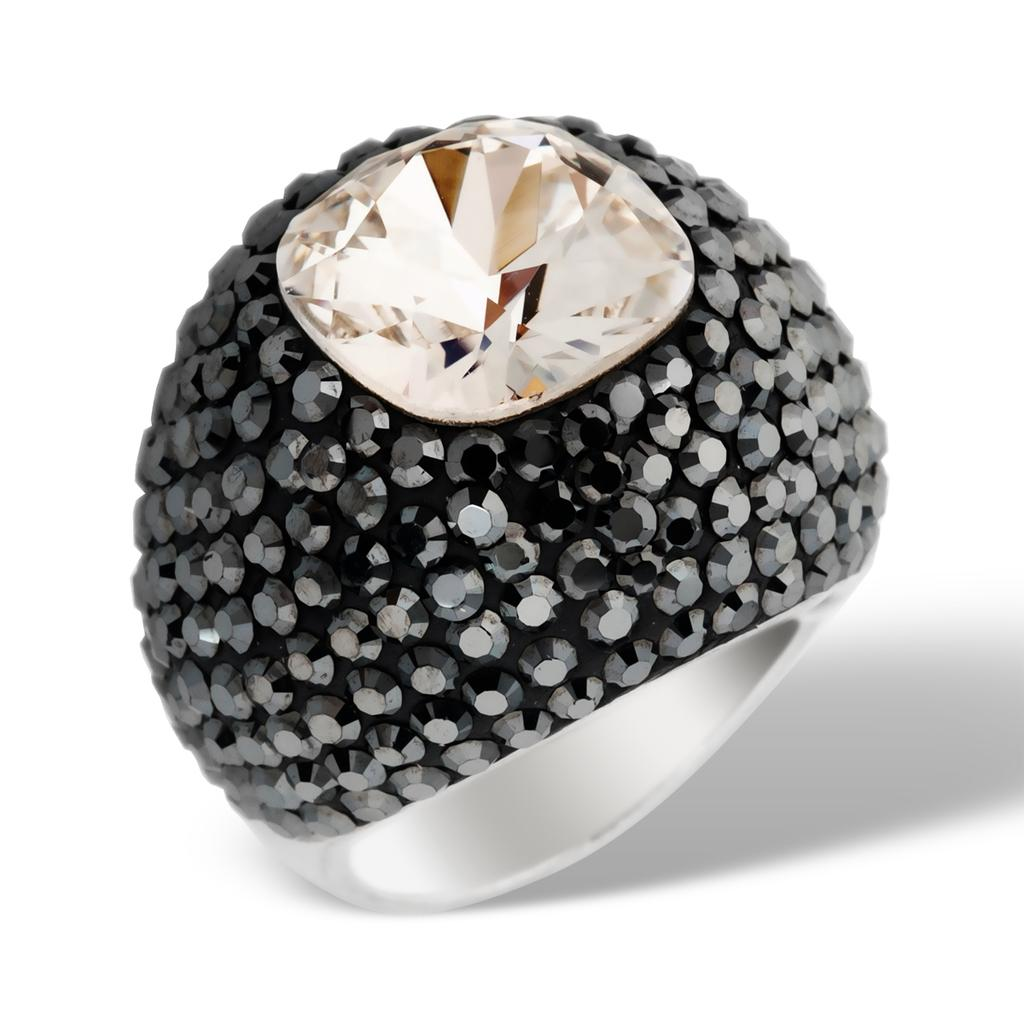What is the main object in the image? There is a diamond ring in the image. What color is the background of the image? The background of the image is white in color. Can you see any sheep grazing near the diamond ring in the image? There are no sheep present in the image. What type of tool is used to cut the diamond ring in the image? There is no tool or action of cutting the diamond ring in the image. 